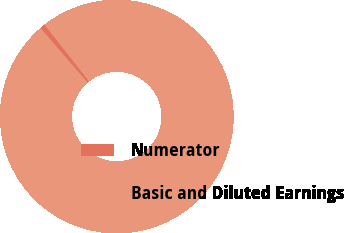Convert chart. <chart><loc_0><loc_0><loc_500><loc_500><pie_chart><fcel>Numerator<fcel>Basic and Diluted Earnings<nl><fcel>0.72%<fcel>99.28%<nl></chart> 